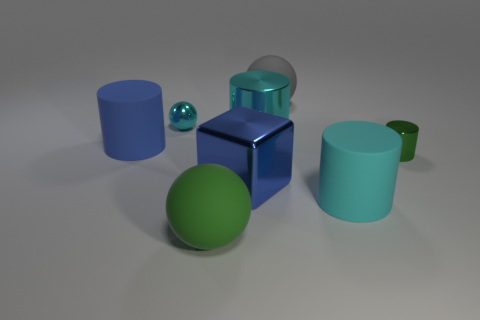There is a cyan shiny sphere that is behind the large blue object that is on the right side of the large matte ball that is in front of the blue cylinder; how big is it?
Offer a terse response. Small. Are there more large matte balls that are in front of the tiny shiny cylinder than gray metal balls?
Offer a very short reply. Yes. Are any large purple metal cubes visible?
Make the answer very short. No. How many metal things have the same size as the green cylinder?
Offer a very short reply. 1. Are there more tiny green shiny cylinders that are in front of the gray object than green metallic things that are in front of the large green ball?
Give a very brief answer. Yes. What material is the green sphere that is the same size as the blue metal block?
Your answer should be very brief. Rubber. What is the shape of the blue shiny object?
Keep it short and to the point. Cube. What number of green objects are either shiny things or small balls?
Offer a terse response. 1. The green cylinder that is made of the same material as the cube is what size?
Provide a short and direct response. Small. Do the ball behind the small metal sphere and the small thing behind the small cylinder have the same material?
Make the answer very short. No. 